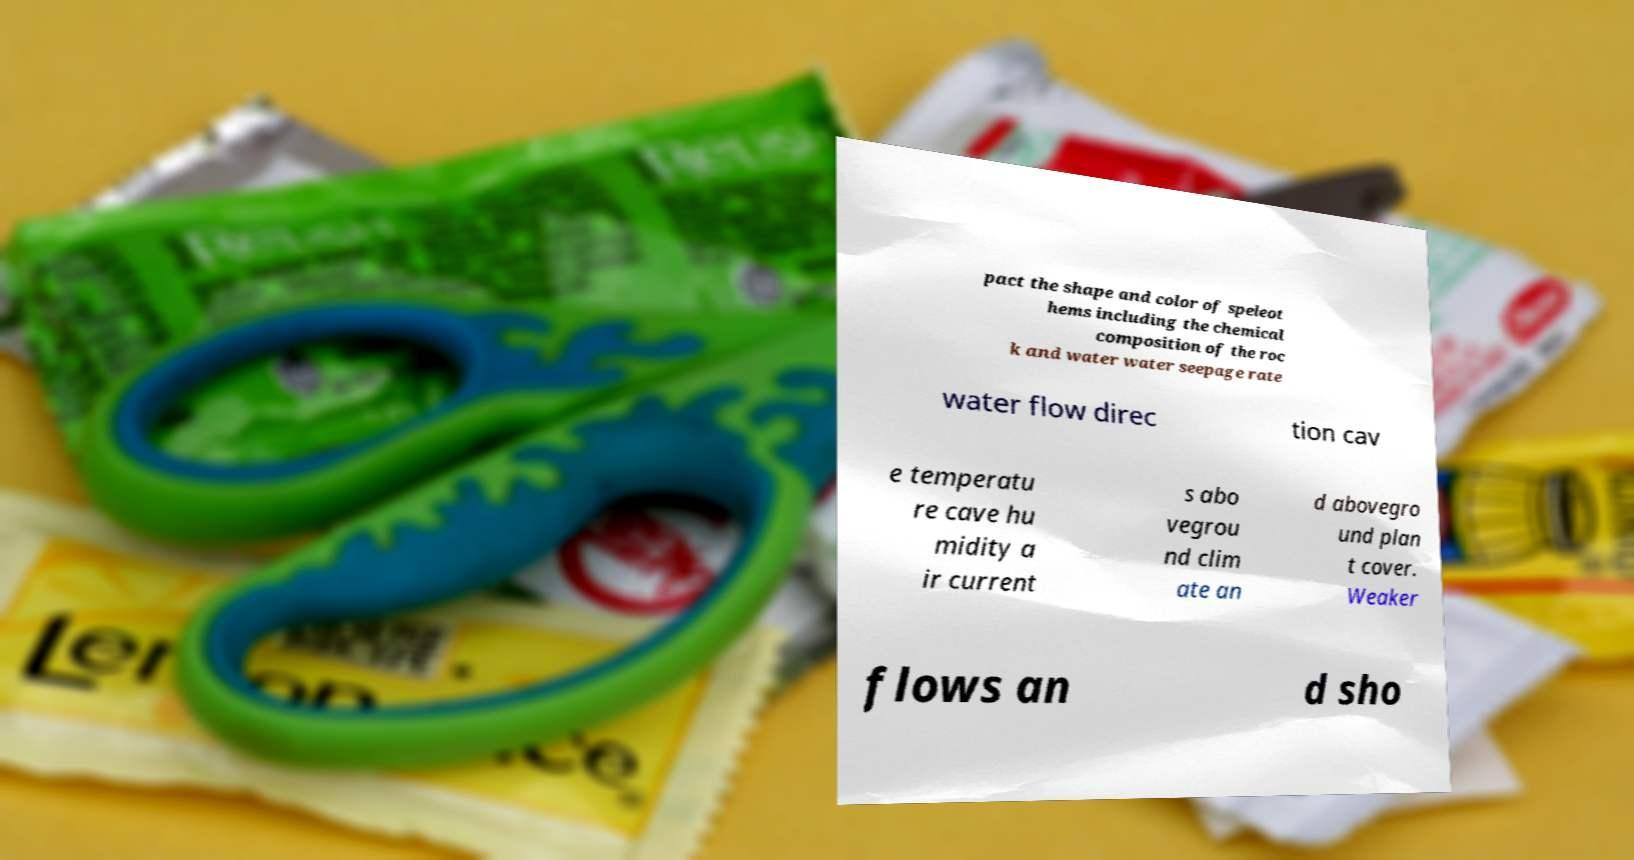There's text embedded in this image that I need extracted. Can you transcribe it verbatim? pact the shape and color of speleot hems including the chemical composition of the roc k and water water seepage rate water flow direc tion cav e temperatu re cave hu midity a ir current s abo vegrou nd clim ate an d abovegro und plan t cover. Weaker flows an d sho 